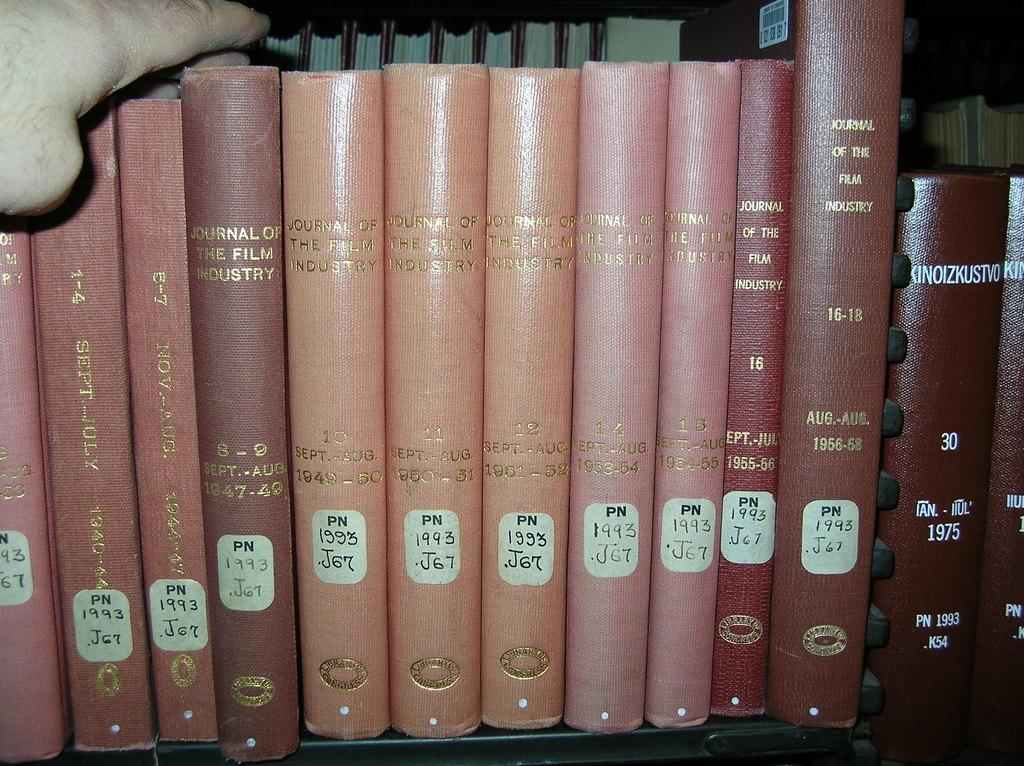<image>
Summarize the visual content of the image. A row of books including Journal of the Film Industry. 